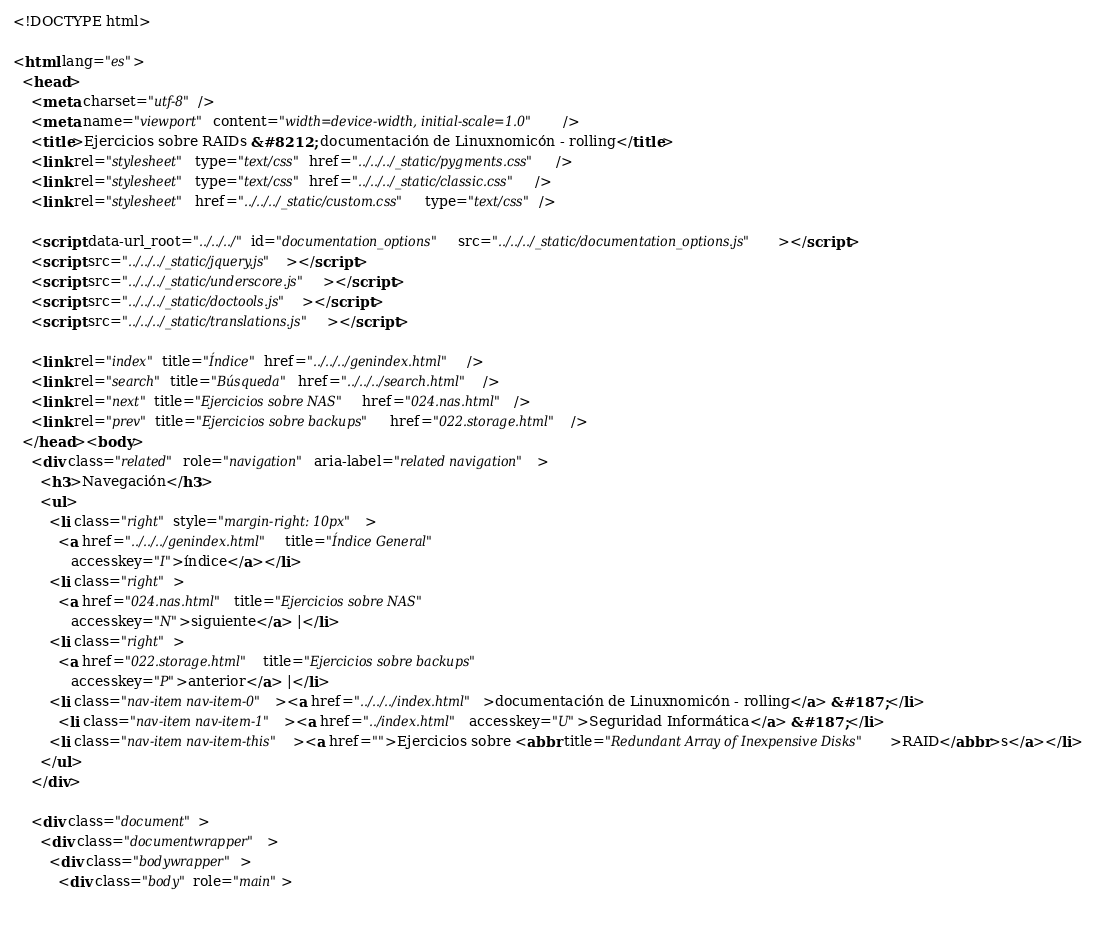Convert code to text. <code><loc_0><loc_0><loc_500><loc_500><_HTML_>


<!DOCTYPE html>

<html lang="es">
  <head>
    <meta charset="utf-8" />
    <meta name="viewport" content="width=device-width, initial-scale=1.0" />
    <title>Ejercicios sobre RAIDs &#8212; documentación de Linuxnomicón - rolling</title>
    <link rel="stylesheet" type="text/css" href="../../../_static/pygments.css" />
    <link rel="stylesheet" type="text/css" href="../../../_static/classic.css" />
    <link rel="stylesheet" href="../../../_static/custom.css" type="text/css" />
    
    <script data-url_root="../../../" id="documentation_options" src="../../../_static/documentation_options.js"></script>
    <script src="../../../_static/jquery.js"></script>
    <script src="../../../_static/underscore.js"></script>
    <script src="../../../_static/doctools.js"></script>
    <script src="../../../_static/translations.js"></script>
    
    <link rel="index" title="Índice" href="../../../genindex.html" />
    <link rel="search" title="Búsqueda" href="../../../search.html" />
    <link rel="next" title="Ejercicios sobre NAS" href="024.nas.html" />
    <link rel="prev" title="Ejercicios sobre backups" href="022.storage.html" /> 
  </head><body>
    <div class="related" role="navigation" aria-label="related navigation">
      <h3>Navegación</h3>
      <ul>
        <li class="right" style="margin-right: 10px">
          <a href="../../../genindex.html" title="Índice General"
             accesskey="I">índice</a></li>
        <li class="right" >
          <a href="024.nas.html" title="Ejercicios sobre NAS"
             accesskey="N">siguiente</a> |</li>
        <li class="right" >
          <a href="022.storage.html" title="Ejercicios sobre backups"
             accesskey="P">anterior</a> |</li>
        <li class="nav-item nav-item-0"><a href="../../../index.html">documentación de Linuxnomicón - rolling</a> &#187;</li>
          <li class="nav-item nav-item-1"><a href="../index.html" accesskey="U">Seguridad Informática</a> &#187;</li>
        <li class="nav-item nav-item-this"><a href="">Ejercicios sobre <abbr title="Redundant Array of Inexpensive Disks">RAID</abbr>s</a></li> 
      </ul>
    </div>  

    <div class="document">
      <div class="documentwrapper">
        <div class="bodywrapper">
          <div class="body" role="main">
            </code> 